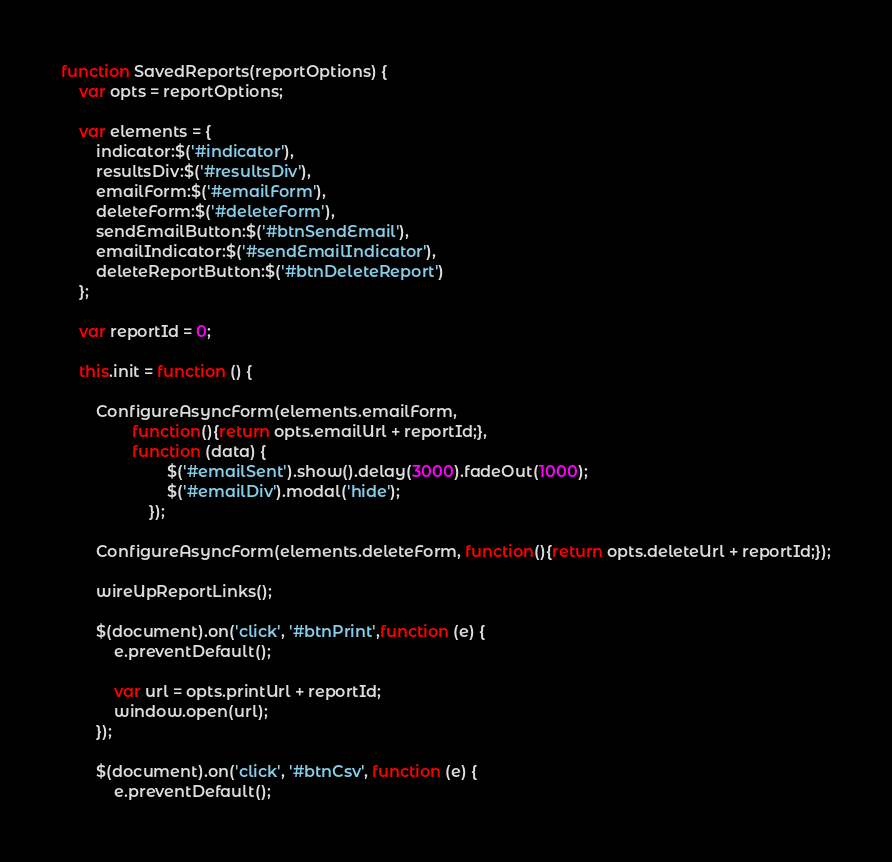<code> <loc_0><loc_0><loc_500><loc_500><_JavaScript_>function SavedReports(reportOptions) {
	var opts = reportOptions;

	var elements = {
		indicator:$('#indicator'),
		resultsDiv:$('#resultsDiv'),
		emailForm:$('#emailForm'),
		deleteForm:$('#deleteForm'),
		sendEmailButton:$('#btnSendEmail'),
		emailIndicator:$('#sendEmailIndicator'),
		deleteReportButton:$('#btnDeleteReport')
	};

	var reportId = 0;

	this.init = function () {

		ConfigureAsyncForm(elements.emailForm,
				function(){return opts.emailUrl + reportId;},
				function (data) {
						$('#emailSent').show().delay(3000).fadeOut(1000);
						$('#emailDiv').modal('hide');
					});

		ConfigureAsyncForm(elements.deleteForm, function(){return opts.deleteUrl + reportId;});

		wireUpReportLinks();

		$(document).on('click', '#btnPrint',function (e) {
			e.preventDefault();

			var url = opts.printUrl + reportId;
			window.open(url);
		});

		$(document).on('click', '#btnCsv', function (e) {
			e.preventDefault();
</code> 